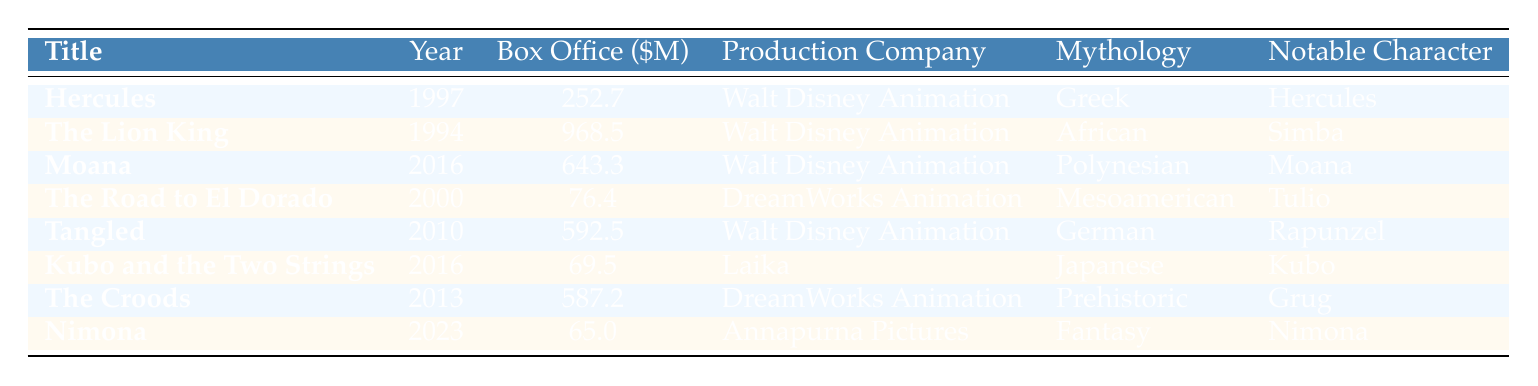What's the box office gross for "The Lion King"? The box office gross for "The Lion King" is explicitly listed in the table, showing 968.5 million dollars.
Answer: 968.5 Which production company was responsible for "Moana"? The table clearly shows that "Moana" was produced by Walt Disney Animation, as listed in the corresponding row.
Answer: Walt Disney Animation Is "Nimona" based on mythology? The table indicates that "Nimona" is labeled as being based on "Fantasy (Loosely based)", which does not align with the category of mythology. Therefore, the answer is no.
Answer: No What is the average box office gross for the films listed in the table? To find the average, first sum all the box office grosses: 252.7 + 968.5 + 643.3 + 76.4 + 592.5 + 69.5 + 587.2 + 65.0 = 3,394.1 million. There are 8 films, so the average is 3,394.1 / 8 = 424.2625 million. Rounded, this is approximately 424.3 million.
Answer: 424.3 Which film has the highest box office gross, and how much did it earn? Examining the table, "The Lion King" has the highest box office gross of 968.5 million dollars, clearly indicated in the respective row.
Answer: The Lion King, 968.5 How many films were produced by Walt Disney Animation? By counting the rows under the production company "Walt Disney Animation", we see that there are 4 films: "Hercules", "The Lion King", "Moana", and "Tangled".
Answer: 4 What is the difference in box office gross between "The Croods" and "Kubo and the Two Strings"? The box office gross for "The Croods" is 587.2 million and for "Kubo and the Two Strings" is 69.5 million. The difference is calculated as 587.2 - 69.5 = 517.7 million.
Answer: 517.7 Which films feature characters from German mythology or fairy tales? The table shows that "Tangled" is based on German (Grimm's Fairy Tale), which means it is the only film on this list connected to German mythology or fairy tales.
Answer: Tangled 